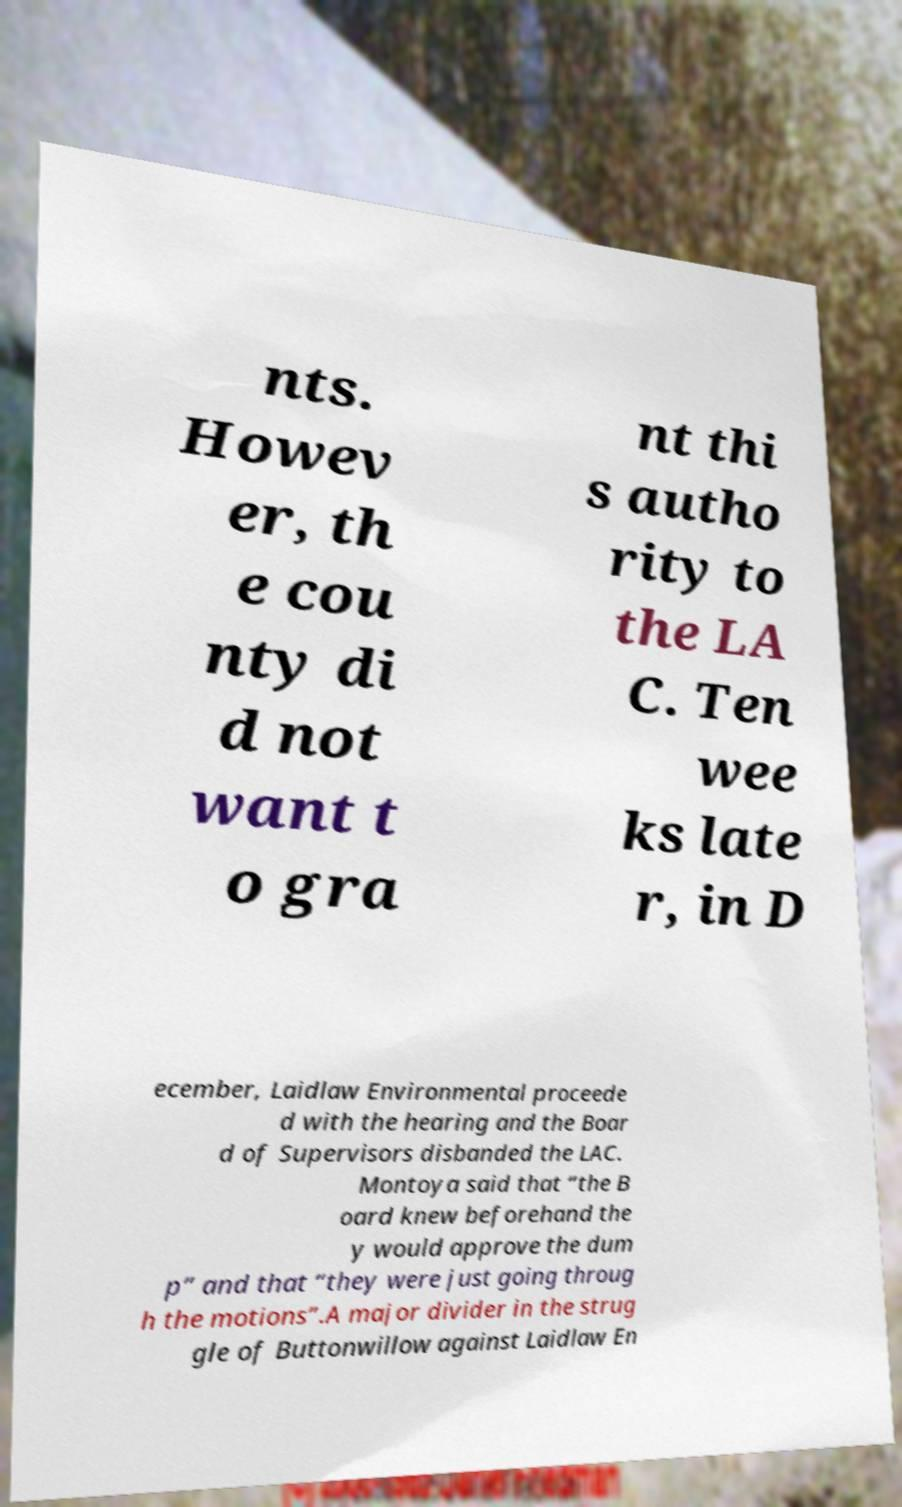For documentation purposes, I need the text within this image transcribed. Could you provide that? nts. Howev er, th e cou nty di d not want t o gra nt thi s autho rity to the LA C. Ten wee ks late r, in D ecember, Laidlaw Environmental proceede d with the hearing and the Boar d of Supervisors disbanded the LAC. Montoya said that “the B oard knew beforehand the y would approve the dum p” and that “they were just going throug h the motions”.A major divider in the strug gle of Buttonwillow against Laidlaw En 